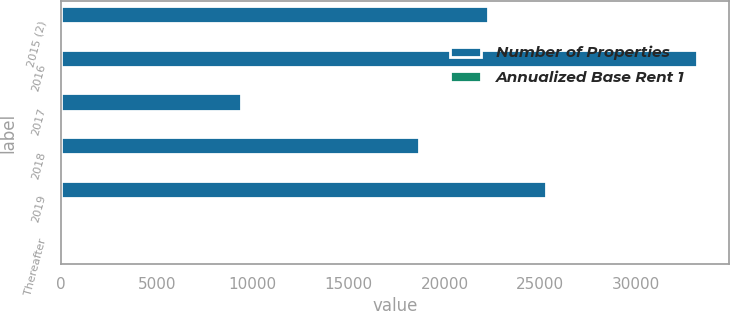Convert chart. <chart><loc_0><loc_0><loc_500><loc_500><stacked_bar_chart><ecel><fcel>2015 (2)<fcel>2016<fcel>2017<fcel>2018<fcel>2019<fcel>Thereafter<nl><fcel>Number of Properties<fcel>22257<fcel>33188<fcel>9393<fcel>18697<fcel>25304<fcel>33<nl><fcel>Annualized Base Rent 1<fcel>28<fcel>10<fcel>3<fcel>4<fcel>14<fcel>33<nl></chart> 